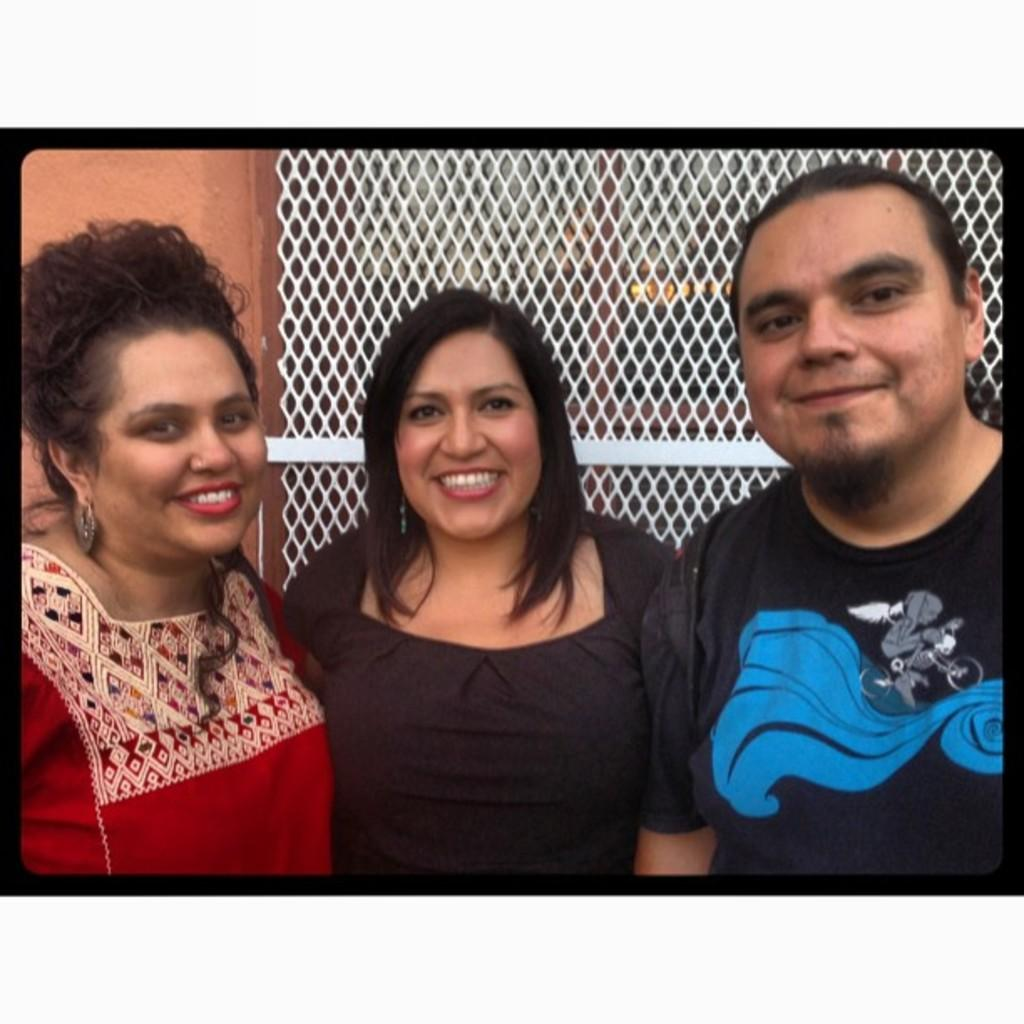How many people are in the image? There are three persons in the image. Where are the persons located in relation to the wall? The persons are standing near a wall. What feature of the wall is visible in the image? There are windows attached to the wall in the image. How many times did the person in the middle kick the dime in the image? There is no dime present in the image, and therefore no kicking action can be observed. 